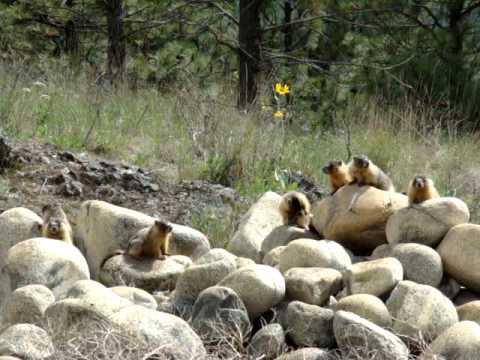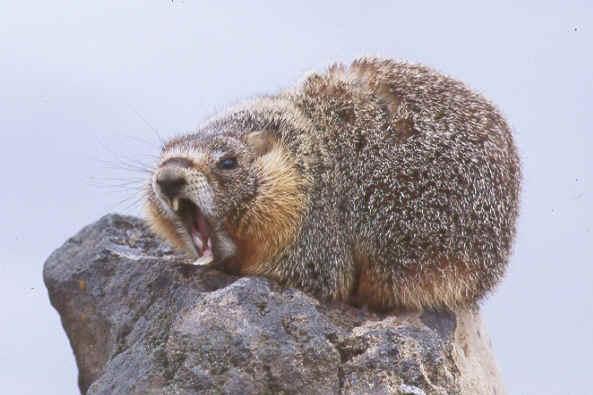The first image is the image on the left, the second image is the image on the right. Evaluate the accuracy of this statement regarding the images: "An image shows a row of four prairie dog type animals, standing upright eating crackers.". Is it true? Answer yes or no. No. 